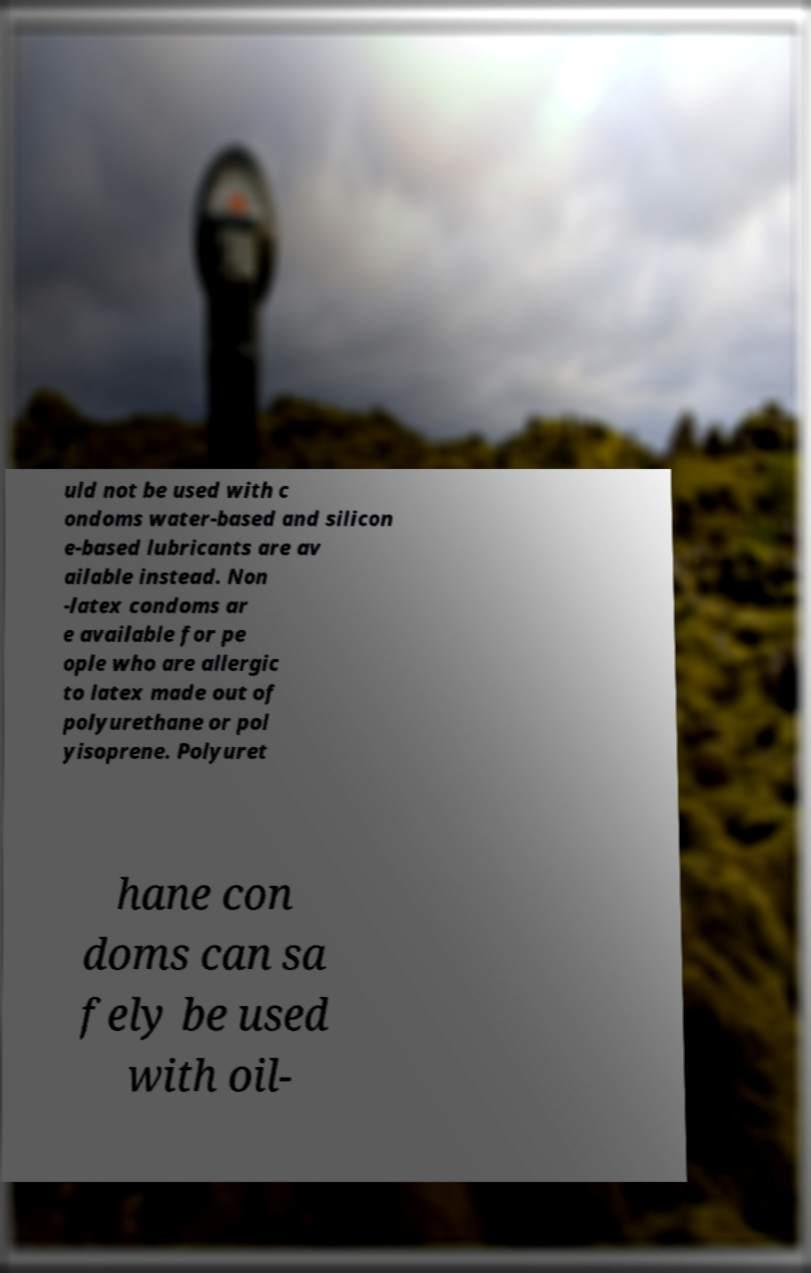Could you extract and type out the text from this image? uld not be used with c ondoms water-based and silicon e-based lubricants are av ailable instead. Non -latex condoms ar e available for pe ople who are allergic to latex made out of polyurethane or pol yisoprene. Polyuret hane con doms can sa fely be used with oil- 